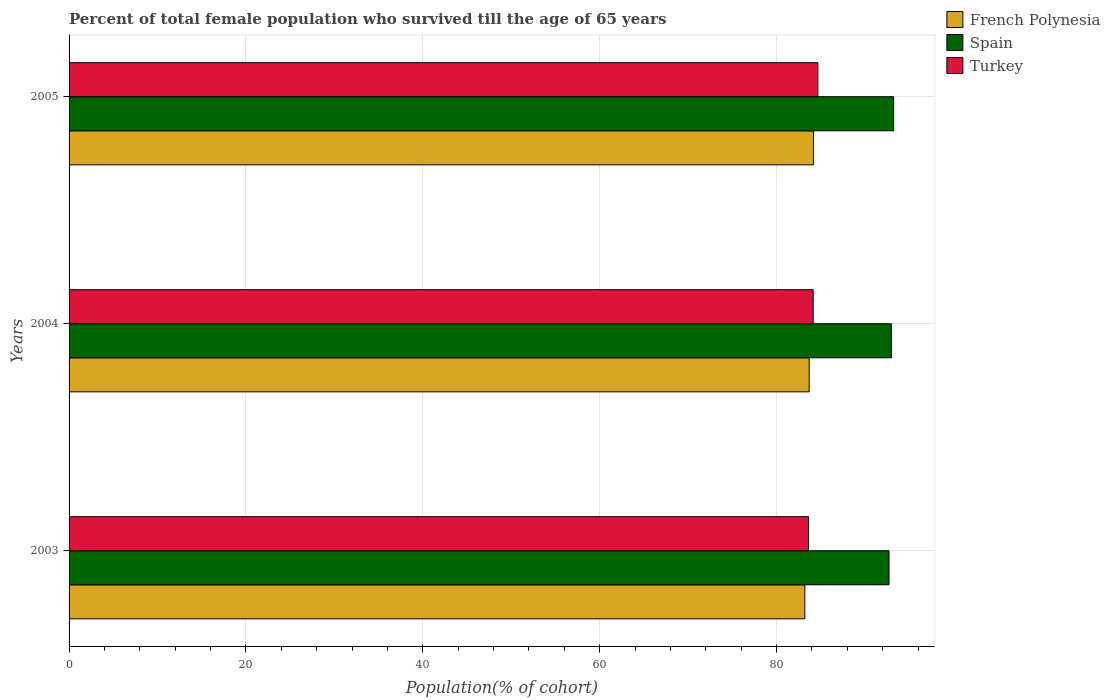How many bars are there on the 2nd tick from the top?
Offer a terse response. 3. What is the percentage of total female population who survived till the age of 65 years in French Polynesia in 2005?
Provide a short and direct response. 84.18. Across all years, what is the maximum percentage of total female population who survived till the age of 65 years in French Polynesia?
Give a very brief answer. 84.18. Across all years, what is the minimum percentage of total female population who survived till the age of 65 years in Spain?
Offer a very short reply. 92.72. What is the total percentage of total female population who survived till the age of 65 years in Spain in the graph?
Give a very brief answer. 278.95. What is the difference between the percentage of total female population who survived till the age of 65 years in French Polynesia in 2003 and that in 2004?
Your answer should be very brief. -0.49. What is the difference between the percentage of total female population who survived till the age of 65 years in Spain in 2004 and the percentage of total female population who survived till the age of 65 years in Turkey in 2003?
Offer a terse response. 9.37. What is the average percentage of total female population who survived till the age of 65 years in French Polynesia per year?
Your response must be concise. 83.69. In the year 2003, what is the difference between the percentage of total female population who survived till the age of 65 years in Spain and percentage of total female population who survived till the age of 65 years in Turkey?
Give a very brief answer. 9.11. What is the ratio of the percentage of total female population who survived till the age of 65 years in French Polynesia in 2003 to that in 2004?
Offer a terse response. 0.99. Is the difference between the percentage of total female population who survived till the age of 65 years in Spain in 2003 and 2005 greater than the difference between the percentage of total female population who survived till the age of 65 years in Turkey in 2003 and 2005?
Give a very brief answer. Yes. What is the difference between the highest and the second highest percentage of total female population who survived till the age of 65 years in Spain?
Your answer should be compact. 0.26. What is the difference between the highest and the lowest percentage of total female population who survived till the age of 65 years in Spain?
Offer a terse response. 0.52. In how many years, is the percentage of total female population who survived till the age of 65 years in Spain greater than the average percentage of total female population who survived till the age of 65 years in Spain taken over all years?
Give a very brief answer. 1. What does the 3rd bar from the top in 2004 represents?
Make the answer very short. French Polynesia. What does the 1st bar from the bottom in 2003 represents?
Your response must be concise. French Polynesia. Are all the bars in the graph horizontal?
Keep it short and to the point. Yes. How many years are there in the graph?
Your answer should be very brief. 3. What is the difference between two consecutive major ticks on the X-axis?
Ensure brevity in your answer.  20. Does the graph contain grids?
Your answer should be very brief. Yes. How are the legend labels stacked?
Provide a short and direct response. Vertical. What is the title of the graph?
Provide a short and direct response. Percent of total female population who survived till the age of 65 years. What is the label or title of the X-axis?
Provide a short and direct response. Population(% of cohort). What is the Population(% of cohort) of French Polynesia in 2003?
Ensure brevity in your answer.  83.2. What is the Population(% of cohort) in Spain in 2003?
Provide a short and direct response. 92.72. What is the Population(% of cohort) in Turkey in 2003?
Provide a succinct answer. 83.61. What is the Population(% of cohort) of French Polynesia in 2004?
Provide a short and direct response. 83.69. What is the Population(% of cohort) of Spain in 2004?
Your answer should be very brief. 92.98. What is the Population(% of cohort) of Turkey in 2004?
Offer a very short reply. 84.14. What is the Population(% of cohort) of French Polynesia in 2005?
Provide a short and direct response. 84.18. What is the Population(% of cohort) in Spain in 2005?
Provide a succinct answer. 93.24. What is the Population(% of cohort) in Turkey in 2005?
Your answer should be very brief. 84.67. Across all years, what is the maximum Population(% of cohort) of French Polynesia?
Offer a terse response. 84.18. Across all years, what is the maximum Population(% of cohort) in Spain?
Keep it short and to the point. 93.24. Across all years, what is the maximum Population(% of cohort) of Turkey?
Your answer should be compact. 84.67. Across all years, what is the minimum Population(% of cohort) in French Polynesia?
Your response must be concise. 83.2. Across all years, what is the minimum Population(% of cohort) in Spain?
Provide a succinct answer. 92.72. Across all years, what is the minimum Population(% of cohort) in Turkey?
Offer a terse response. 83.61. What is the total Population(% of cohort) of French Polynesia in the graph?
Offer a very short reply. 251.08. What is the total Population(% of cohort) of Spain in the graph?
Ensure brevity in your answer.  278.95. What is the total Population(% of cohort) of Turkey in the graph?
Ensure brevity in your answer.  252.42. What is the difference between the Population(% of cohort) of French Polynesia in 2003 and that in 2004?
Give a very brief answer. -0.49. What is the difference between the Population(% of cohort) in Spain in 2003 and that in 2004?
Keep it short and to the point. -0.26. What is the difference between the Population(% of cohort) of Turkey in 2003 and that in 2004?
Offer a terse response. -0.53. What is the difference between the Population(% of cohort) of French Polynesia in 2003 and that in 2005?
Give a very brief answer. -0.98. What is the difference between the Population(% of cohort) in Spain in 2003 and that in 2005?
Your response must be concise. -0.52. What is the difference between the Population(% of cohort) in Turkey in 2003 and that in 2005?
Give a very brief answer. -1.06. What is the difference between the Population(% of cohort) of French Polynesia in 2004 and that in 2005?
Keep it short and to the point. -0.49. What is the difference between the Population(% of cohort) of Spain in 2004 and that in 2005?
Your answer should be compact. -0.26. What is the difference between the Population(% of cohort) in Turkey in 2004 and that in 2005?
Give a very brief answer. -0.53. What is the difference between the Population(% of cohort) of French Polynesia in 2003 and the Population(% of cohort) of Spain in 2004?
Provide a succinct answer. -9.78. What is the difference between the Population(% of cohort) of French Polynesia in 2003 and the Population(% of cohort) of Turkey in 2004?
Keep it short and to the point. -0.94. What is the difference between the Population(% of cohort) in Spain in 2003 and the Population(% of cohort) in Turkey in 2004?
Your response must be concise. 8.58. What is the difference between the Population(% of cohort) in French Polynesia in 2003 and the Population(% of cohort) in Spain in 2005?
Make the answer very short. -10.04. What is the difference between the Population(% of cohort) of French Polynesia in 2003 and the Population(% of cohort) of Turkey in 2005?
Provide a short and direct response. -1.47. What is the difference between the Population(% of cohort) in Spain in 2003 and the Population(% of cohort) in Turkey in 2005?
Make the answer very short. 8.05. What is the difference between the Population(% of cohort) in French Polynesia in 2004 and the Population(% of cohort) in Spain in 2005?
Offer a very short reply. -9.55. What is the difference between the Population(% of cohort) in French Polynesia in 2004 and the Population(% of cohort) in Turkey in 2005?
Offer a terse response. -0.98. What is the difference between the Population(% of cohort) of Spain in 2004 and the Population(% of cohort) of Turkey in 2005?
Make the answer very short. 8.31. What is the average Population(% of cohort) of French Polynesia per year?
Offer a very short reply. 83.69. What is the average Population(% of cohort) in Spain per year?
Offer a very short reply. 92.98. What is the average Population(% of cohort) of Turkey per year?
Your answer should be compact. 84.14. In the year 2003, what is the difference between the Population(% of cohort) of French Polynesia and Population(% of cohort) of Spain?
Your answer should be very brief. -9.52. In the year 2003, what is the difference between the Population(% of cohort) of French Polynesia and Population(% of cohort) of Turkey?
Offer a very short reply. -0.41. In the year 2003, what is the difference between the Population(% of cohort) of Spain and Population(% of cohort) of Turkey?
Your answer should be very brief. 9.11. In the year 2004, what is the difference between the Population(% of cohort) of French Polynesia and Population(% of cohort) of Spain?
Ensure brevity in your answer.  -9.29. In the year 2004, what is the difference between the Population(% of cohort) of French Polynesia and Population(% of cohort) of Turkey?
Your answer should be compact. -0.45. In the year 2004, what is the difference between the Population(% of cohort) of Spain and Population(% of cohort) of Turkey?
Provide a succinct answer. 8.84. In the year 2005, what is the difference between the Population(% of cohort) in French Polynesia and Population(% of cohort) in Spain?
Offer a very short reply. -9.06. In the year 2005, what is the difference between the Population(% of cohort) in French Polynesia and Population(% of cohort) in Turkey?
Offer a terse response. -0.49. In the year 2005, what is the difference between the Population(% of cohort) in Spain and Population(% of cohort) in Turkey?
Offer a terse response. 8.57. What is the ratio of the Population(% of cohort) in French Polynesia in 2003 to that in 2004?
Keep it short and to the point. 0.99. What is the ratio of the Population(% of cohort) of Spain in 2003 to that in 2004?
Your answer should be very brief. 1. What is the ratio of the Population(% of cohort) in French Polynesia in 2003 to that in 2005?
Your answer should be very brief. 0.99. What is the ratio of the Population(% of cohort) in Spain in 2003 to that in 2005?
Keep it short and to the point. 0.99. What is the ratio of the Population(% of cohort) in Turkey in 2003 to that in 2005?
Your answer should be compact. 0.99. What is the ratio of the Population(% of cohort) of French Polynesia in 2004 to that in 2005?
Keep it short and to the point. 0.99. What is the ratio of the Population(% of cohort) of Turkey in 2004 to that in 2005?
Make the answer very short. 0.99. What is the difference between the highest and the second highest Population(% of cohort) of French Polynesia?
Your answer should be very brief. 0.49. What is the difference between the highest and the second highest Population(% of cohort) in Spain?
Give a very brief answer. 0.26. What is the difference between the highest and the second highest Population(% of cohort) in Turkey?
Keep it short and to the point. 0.53. What is the difference between the highest and the lowest Population(% of cohort) of French Polynesia?
Make the answer very short. 0.98. What is the difference between the highest and the lowest Population(% of cohort) of Spain?
Keep it short and to the point. 0.52. What is the difference between the highest and the lowest Population(% of cohort) in Turkey?
Provide a succinct answer. 1.06. 